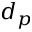<formula> <loc_0><loc_0><loc_500><loc_500>d _ { p }</formula> 